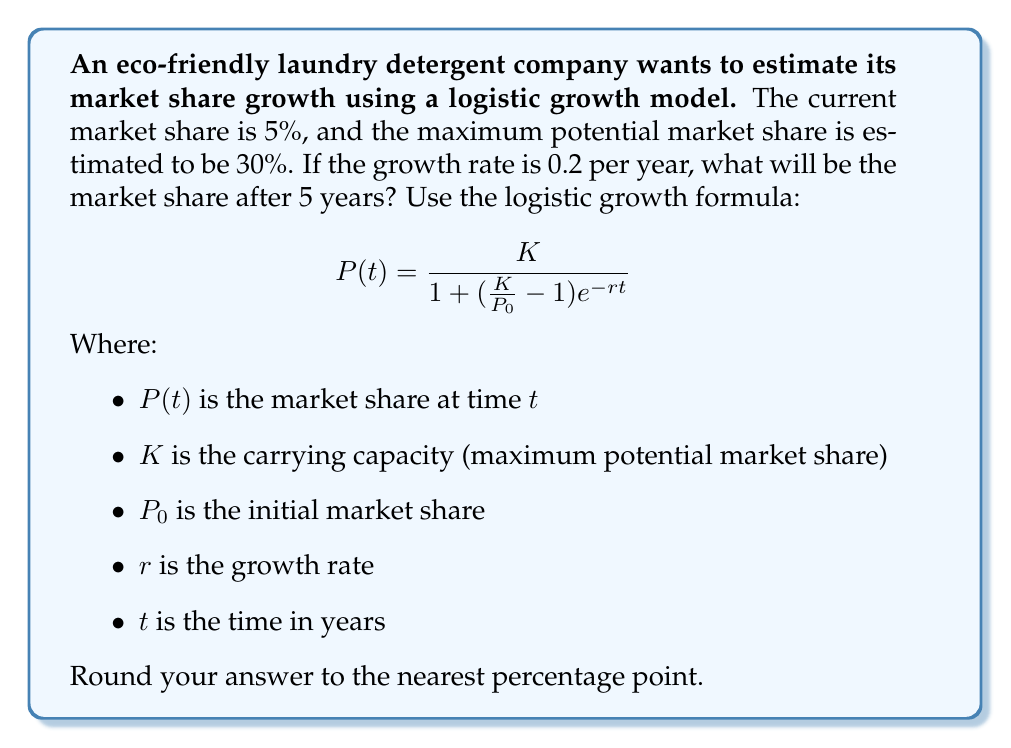Can you solve this math problem? To solve this problem, we'll use the logistic growth formula and plug in the given values:

$K = 30\%$ (maximum potential market share)
$P_0 = 5\%$ (initial market share)
$r = 0.2$ (growth rate per year)
$t = 5$ (time in years)

Let's substitute these values into the formula:

$$P(5) = \frac{30}{1 + (\frac{30}{5} - 1)e^{-0.2 \cdot 5}}$$

Now, let's solve this step by step:

1. Calculate $\frac{30}{5} - 1$:
   $\frac{30}{5} - 1 = 6 - 1 = 5$

2. Calculate $-0.2 \cdot 5$:
   $-0.2 \cdot 5 = -1$

3. Simplify the equation:
   $$P(5) = \frac{30}{1 + 5e^{-1}}$$

4. Calculate $e^{-1}$:
   $e^{-1} \approx 0.3679$

5. Multiply $5 \cdot 0.3679$:
   $5 \cdot 0.3679 \approx 1.8395$

6. Add 1 to the result:
   $1 + 1.8395 = 2.8395$

7. Divide 30 by the result:
   $$P(5) = \frac{30}{2.8395} \approx 10.5653$$

8. Round to the nearest percentage point:
   $10.5653\% \approx 11\%$

Therefore, after 5 years, the market share of the eco-friendly laundry detergent company will be approximately 11%.
Answer: 11% 